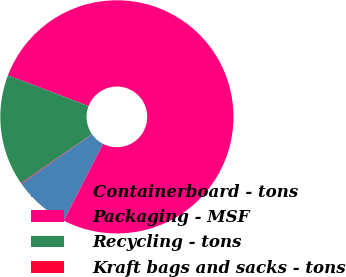Convert chart. <chart><loc_0><loc_0><loc_500><loc_500><pie_chart><fcel>Containerboard - tons<fcel>Packaging - MSF<fcel>Recycling - tons<fcel>Kraft bags and sacks - tons<nl><fcel>7.76%<fcel>76.73%<fcel>15.42%<fcel>0.09%<nl></chart> 